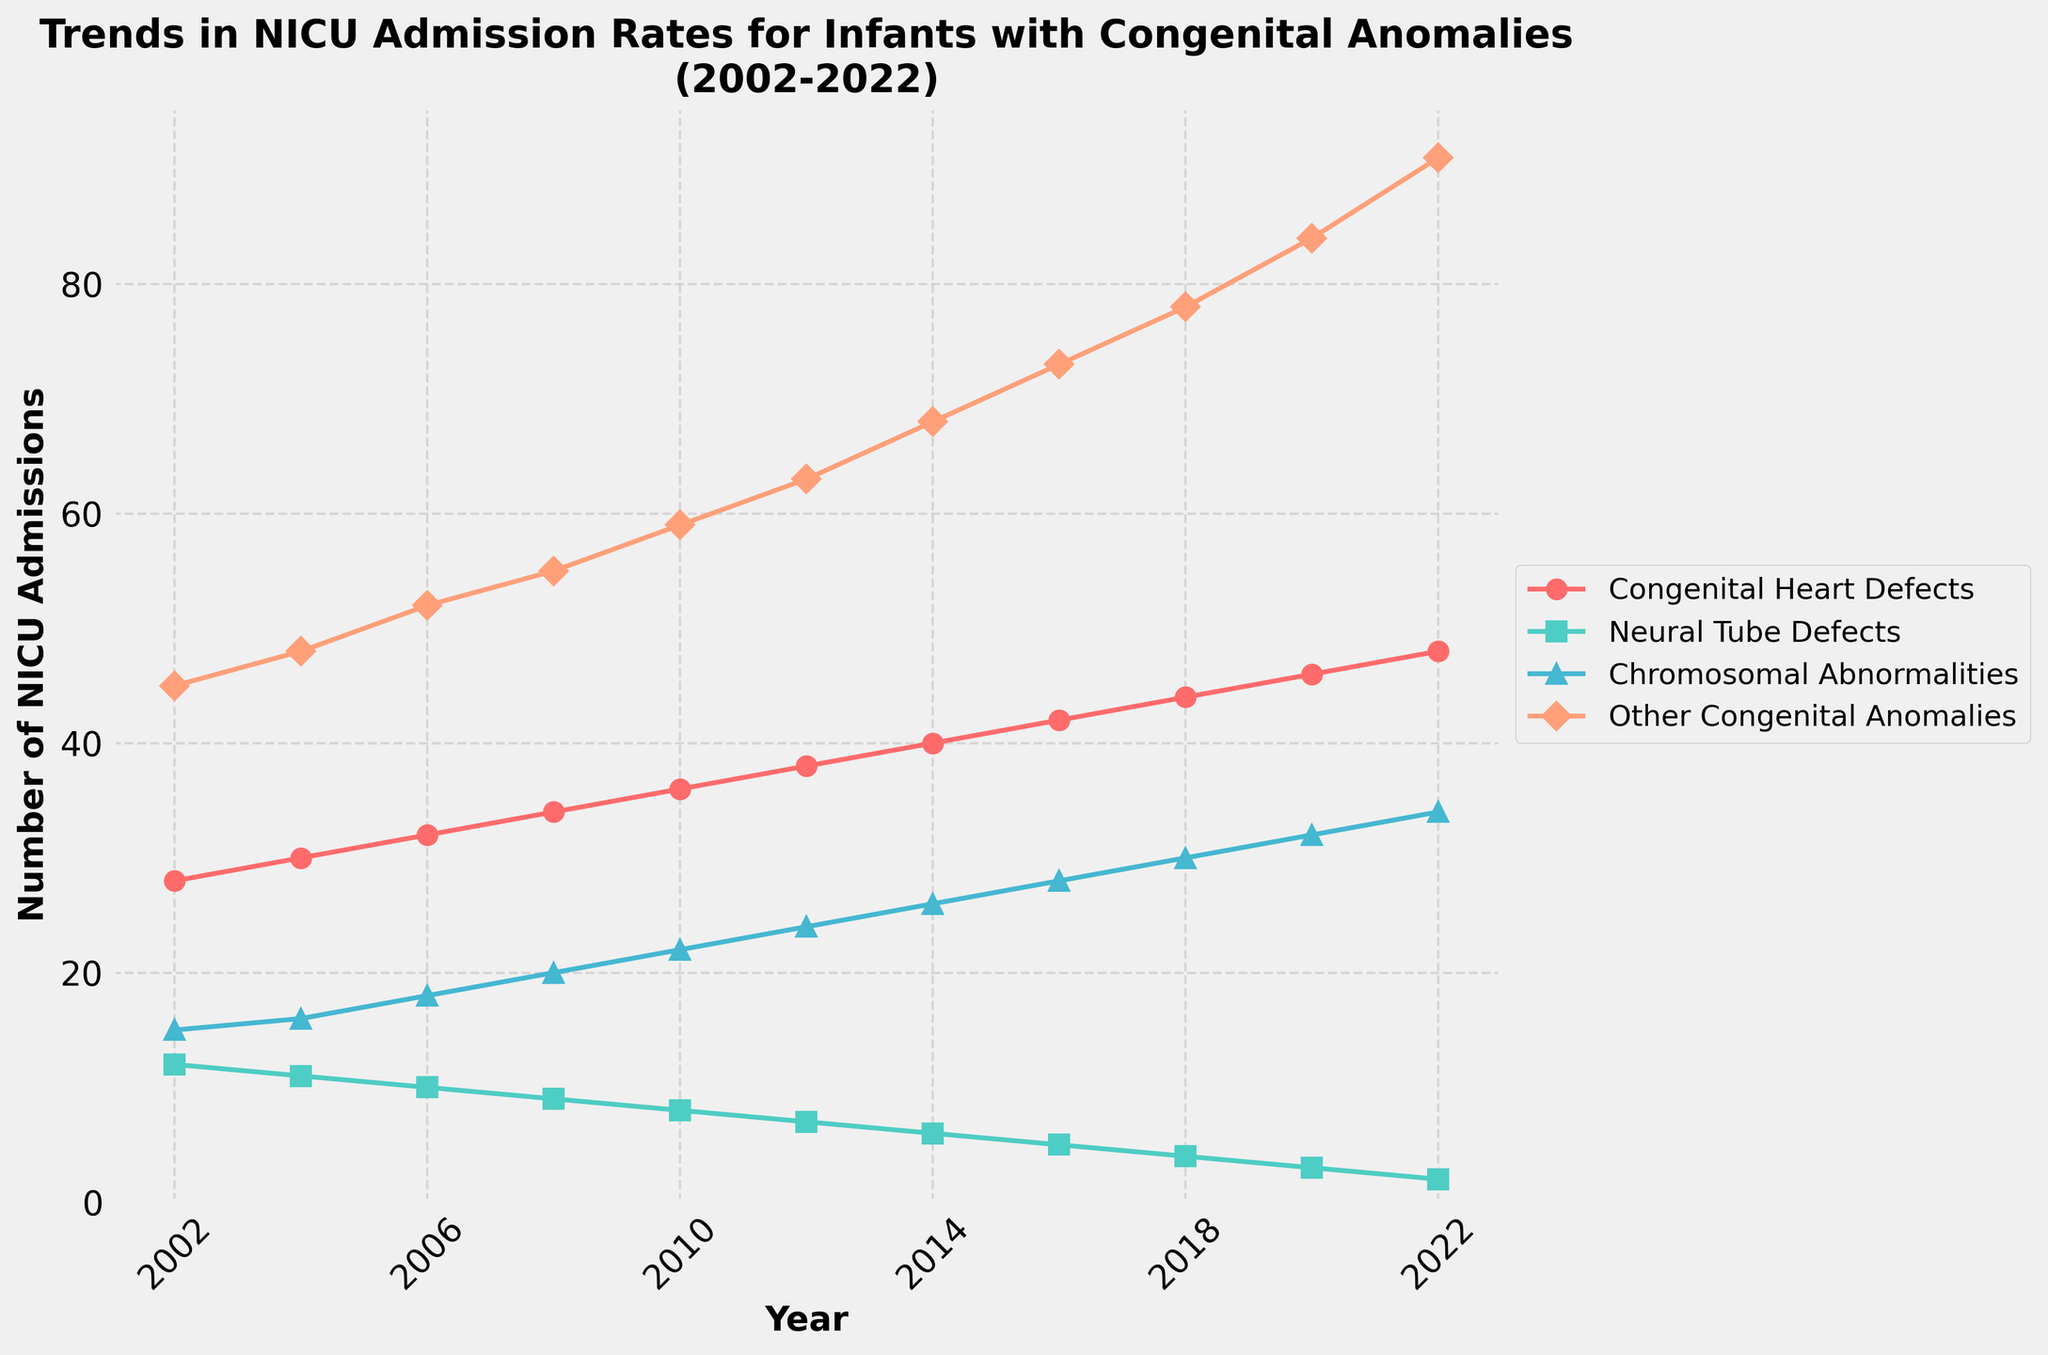What's the overall trend in NICU admissions for infants with Congenital Heart Defects from 2002 to 2022? To identify the overall trend, observe the line representing Congenital Heart Defects. It starts at 28 admissions in 2002 and increases steadily to 48 in 2022. This indicates a consistent upward trend over the years.
Answer: Steadily increasing Which category had the largest increase in NICU admissions from 2002 to 2022? Calculate the differences in admissions for each category between 2002 and 2022: Congenital Heart Defects (48-28=20), Neural Tube Defects (12-2=10), Chromosomal Abnormalities (34-15=19), Other Congenital Anomalies (91-45=46). The category with the largest increase is Other Congenital Anomalies.
Answer: Other Congenital Anomalies In what year did the number of NICU admissions for Neural Tube Defects drop below 10? Look at the line representing Neural Tube Defects. The admissions drop below 10 in the year 2008, where it decreases to 9.
Answer: 2008 Compare the NICU admissions for Chromosomal Abnormalities and Congenital Heart Defects in 2010. Which was higher, and by how much? In 2010, Chromosomal Abnormalities had 22 admissions, and Congenital Heart Defects had 36. The difference is 36 - 22 = 14, with Congenital Heart Defects being higher.
Answer: Congenital Heart Defects by 14 What is the total number of NICU admissions for infants with Congenital Anomalies in 2006? Sum the admissions for all categories in 2006: Congenital Heart Defects (32), Neural Tube Defects (10), Chromosomal Abnormalities (18), Other Congenital Anomalies (52). The total is 32 + 10 + 18 + 52 = 112.
Answer: 112 Examine the visual patterns. Which category has the steepest increase in NICU admissions over time? Look at the steepness of each line's slope. The line representing Other Congenital Anomalies (orange) has the steepest increase, indicating the highest rate of increase.
Answer: Other Congenital Anomalies Which category had the lowest rate of change in admissions from 2002 to 2022? Calculate the rate of change for each category. Neural Tube Defects decreased from 12 to 2, showing the lowest rate of change (in absolute value).
Answer: Neural Tube Defects What were the NICU admissions for Congenital Heart Defects in 2014 relative to the previous even year? What is the percentage change? Admissions in 2012 were 38; in 2014, they were 40. The change is 40 - 38 = 2. The percentage change is (2/38) * 100 ≈ 5.26%.
Answer: ~5.26% increase What is the visual representation color for Chromosomal Abnormalities? Observe the colored lines and their labels. The line representing Chromosomal Abnormalities is blue.
Answer: Blue 